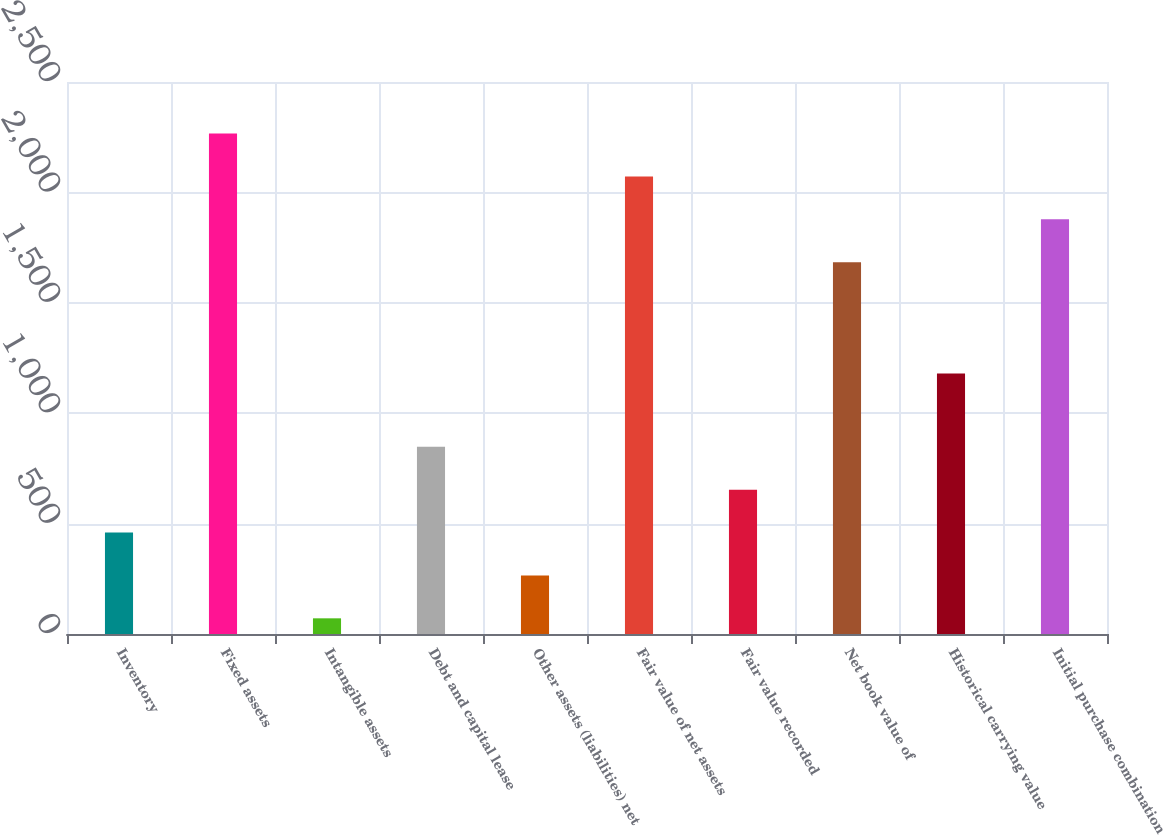<chart> <loc_0><loc_0><loc_500><loc_500><bar_chart><fcel>Inventory<fcel>Fixed assets<fcel>Intangible assets<fcel>Debt and capital lease<fcel>Other assets (liabilities) net<fcel>Fair value of net assets<fcel>Fair value recorded<fcel>Net book value of<fcel>Historical carrying value<fcel>Initial purchase combination<nl><fcel>459.4<fcel>2266.6<fcel>71<fcel>847.8<fcel>265.2<fcel>2072.4<fcel>653.6<fcel>1684<fcel>1180<fcel>1878.2<nl></chart> 